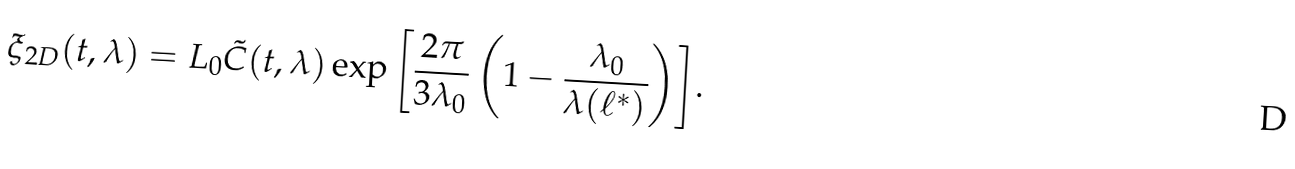<formula> <loc_0><loc_0><loc_500><loc_500>\xi _ { 2 D } ( t , \lambda ) = L _ { 0 } \tilde { C } ( t , \lambda ) \exp { \left [ \frac { 2 \pi } { 3 \lambda _ { 0 } } \left ( 1 - \frac { \lambda _ { 0 } } { \lambda ( \ell ^ { \ast } ) } \right ) \right ] } .</formula> 